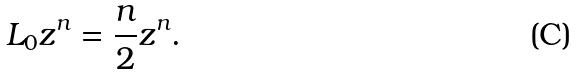<formula> <loc_0><loc_0><loc_500><loc_500>L _ { 0 } z ^ { n } = \frac { n } { 2 } z ^ { n } .</formula> 